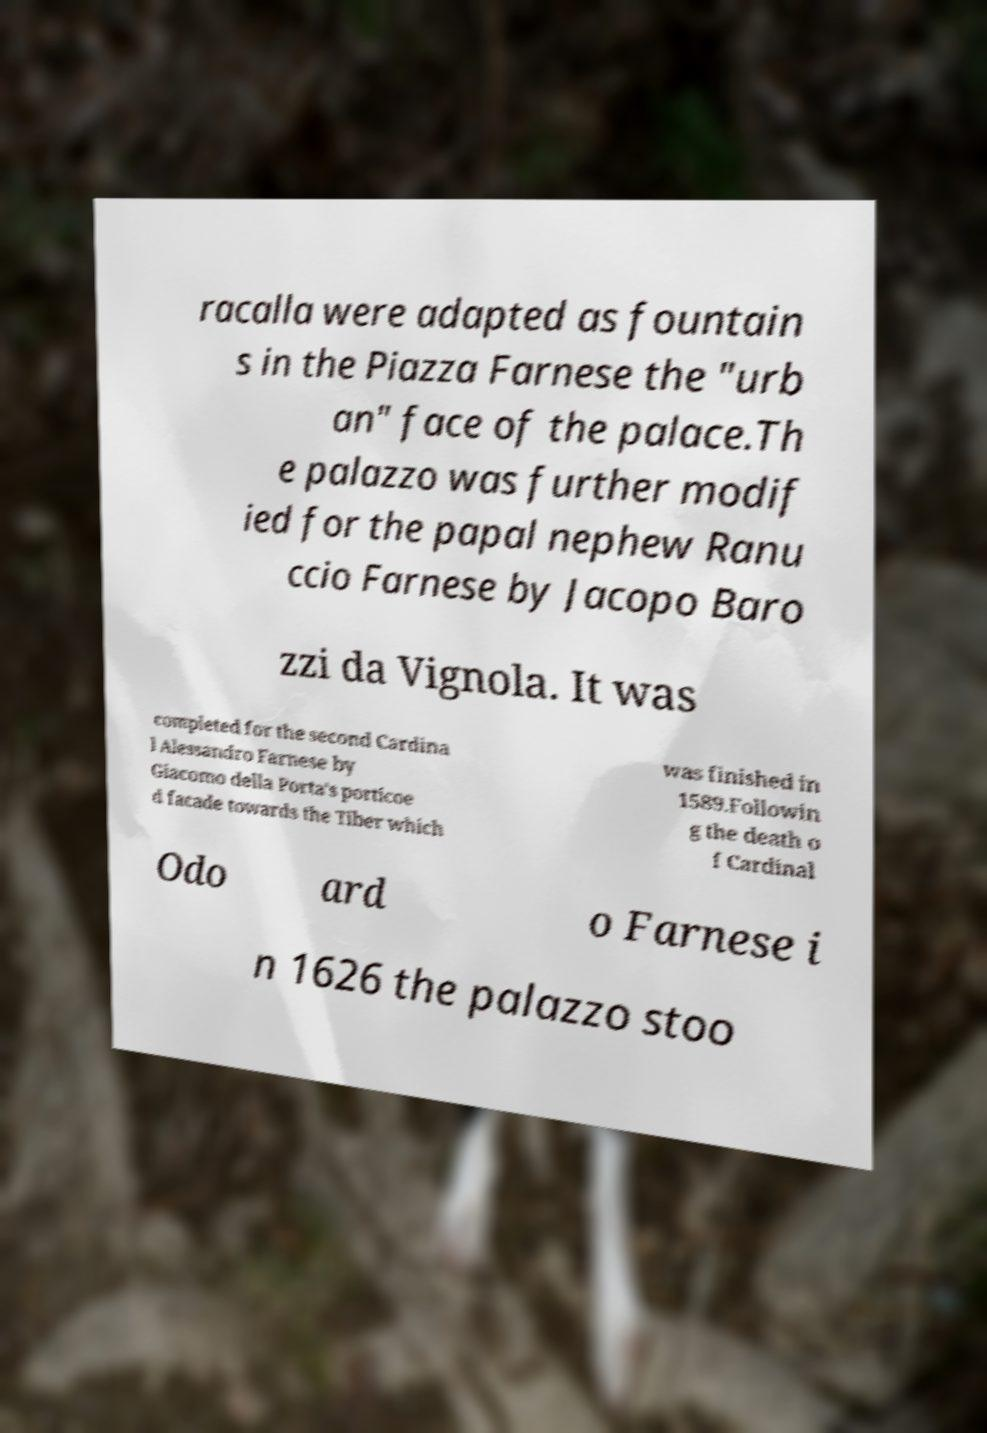There's text embedded in this image that I need extracted. Can you transcribe it verbatim? racalla were adapted as fountain s in the Piazza Farnese the "urb an" face of the palace.Th e palazzo was further modif ied for the papal nephew Ranu ccio Farnese by Jacopo Baro zzi da Vignola. It was completed for the second Cardina l Alessandro Farnese by Giacomo della Porta's porticoe d facade towards the Tiber which was finished in 1589.Followin g the death o f Cardinal Odo ard o Farnese i n 1626 the palazzo stoo 